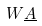<formula> <loc_0><loc_0><loc_500><loc_500>W \underline { A }</formula> 